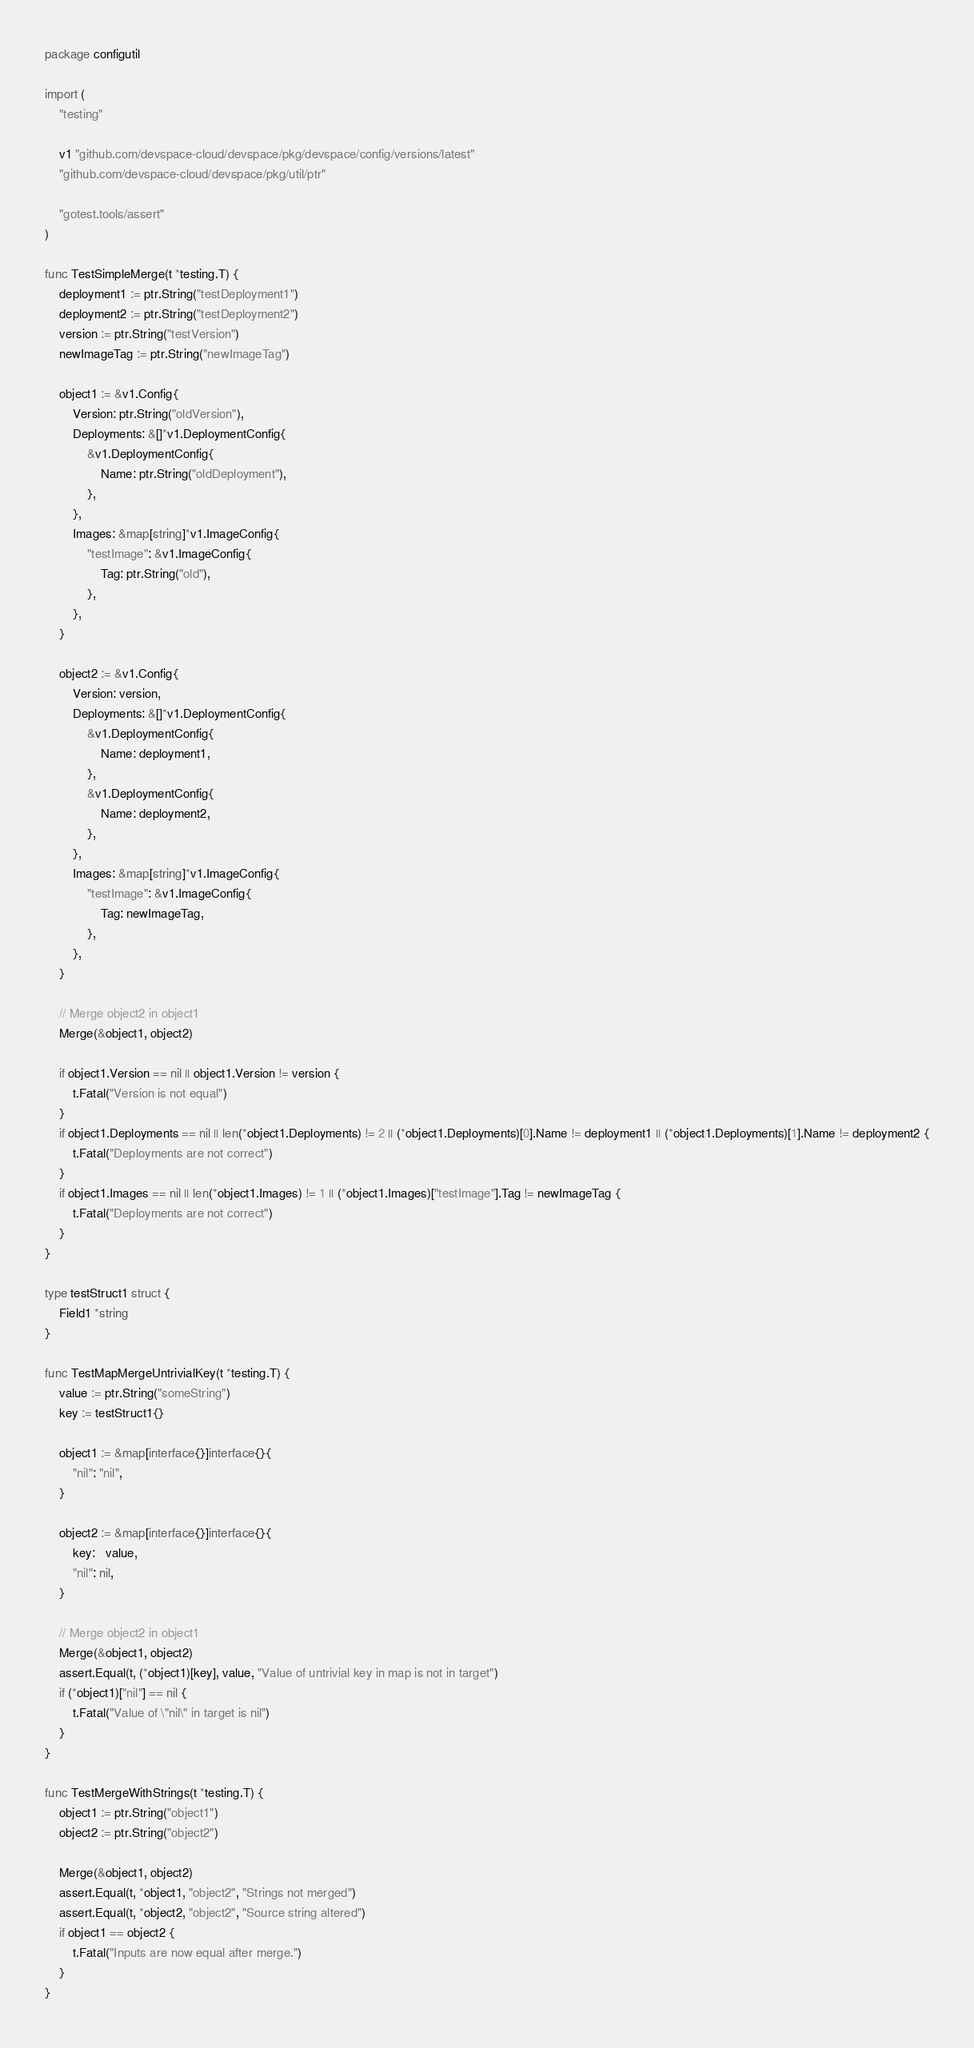Convert code to text. <code><loc_0><loc_0><loc_500><loc_500><_Go_>package configutil

import (
	"testing"

	v1 "github.com/devspace-cloud/devspace/pkg/devspace/config/versions/latest"
	"github.com/devspace-cloud/devspace/pkg/util/ptr"

	"gotest.tools/assert"
)

func TestSimpleMerge(t *testing.T) {
	deployment1 := ptr.String("testDeployment1")
	deployment2 := ptr.String("testDeployment2")
	version := ptr.String("testVersion")
	newImageTag := ptr.String("newImageTag")

	object1 := &v1.Config{
		Version: ptr.String("oldVersion"),
		Deployments: &[]*v1.DeploymentConfig{
			&v1.DeploymentConfig{
				Name: ptr.String("oldDeployment"),
			},
		},
		Images: &map[string]*v1.ImageConfig{
			"testImage": &v1.ImageConfig{
				Tag: ptr.String("old"),
			},
		},
	}

	object2 := &v1.Config{
		Version: version,
		Deployments: &[]*v1.DeploymentConfig{
			&v1.DeploymentConfig{
				Name: deployment1,
			},
			&v1.DeploymentConfig{
				Name: deployment2,
			},
		},
		Images: &map[string]*v1.ImageConfig{
			"testImage": &v1.ImageConfig{
				Tag: newImageTag,
			},
		},
	}

	// Merge object2 in object1
	Merge(&object1, object2)

	if object1.Version == nil || object1.Version != version {
		t.Fatal("Version is not equal")
	}
	if object1.Deployments == nil || len(*object1.Deployments) != 2 || (*object1.Deployments)[0].Name != deployment1 || (*object1.Deployments)[1].Name != deployment2 {
		t.Fatal("Deployments are not correct")
	}
	if object1.Images == nil || len(*object1.Images) != 1 || (*object1.Images)["testImage"].Tag != newImageTag {
		t.Fatal("Deployments are not correct")
	}
}

type testStruct1 struct {
	Field1 *string
}

func TestMapMergeUntrivialKey(t *testing.T) {
	value := ptr.String("someString")
	key := testStruct1{}

	object1 := &map[interface{}]interface{}{
		"nil": "nil",
	}

	object2 := &map[interface{}]interface{}{
		key:   value,
		"nil": nil,
	}

	// Merge object2 in object1
	Merge(&object1, object2)
	assert.Equal(t, (*object1)[key], value, "Value of untrivial key in map is not in target")
	if (*object1)["nil"] == nil {
		t.Fatal("Value of \"nil\" in target is nil")
	}
}

func TestMergeWithStrings(t *testing.T) {
	object1 := ptr.String("object1")
	object2 := ptr.String("object2")

	Merge(&object1, object2)
	assert.Equal(t, *object1, "object2", "Strings not merged")
	assert.Equal(t, *object2, "object2", "Source string altered")
	if object1 == object2 {
		t.Fatal("Inputs are now equal after merge.")
	}
}
</code> 